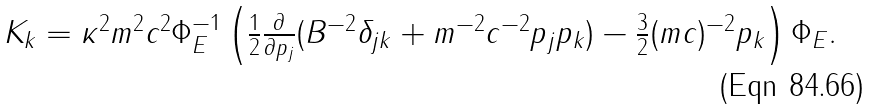Convert formula to latex. <formula><loc_0><loc_0><loc_500><loc_500>\begin{array} { l } K _ { k } = \kappa ^ { 2 } m ^ { 2 } c ^ { 2 } \Phi _ { E } ^ { - 1 } \left ( \frac { 1 } { 2 } \frac { \partial } { \partial p _ { j } } ( B ^ { - 2 } \delta _ { j k } + m ^ { - 2 } c ^ { - 2 } p _ { j } p _ { k } ) - \frac { 3 } { 2 } ( m c ) ^ { - 2 } p _ { k } \right ) \Phi _ { E } . \end{array}</formula> 